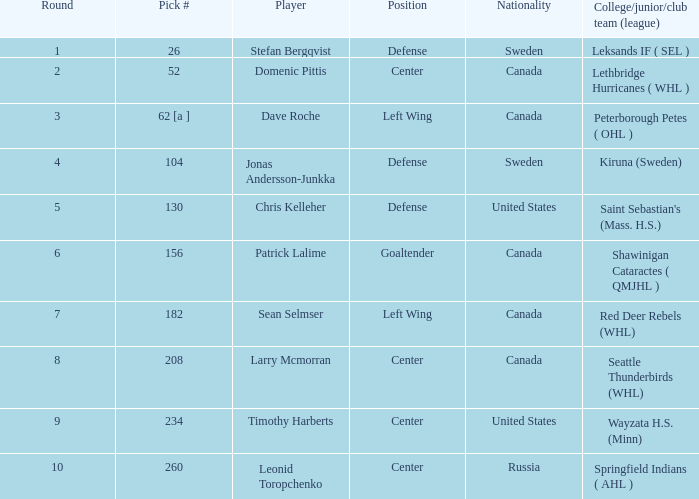What is the college/junior/club team (league) of the player who was pick number 130? Saint Sebastian's (Mass. H.S.). 